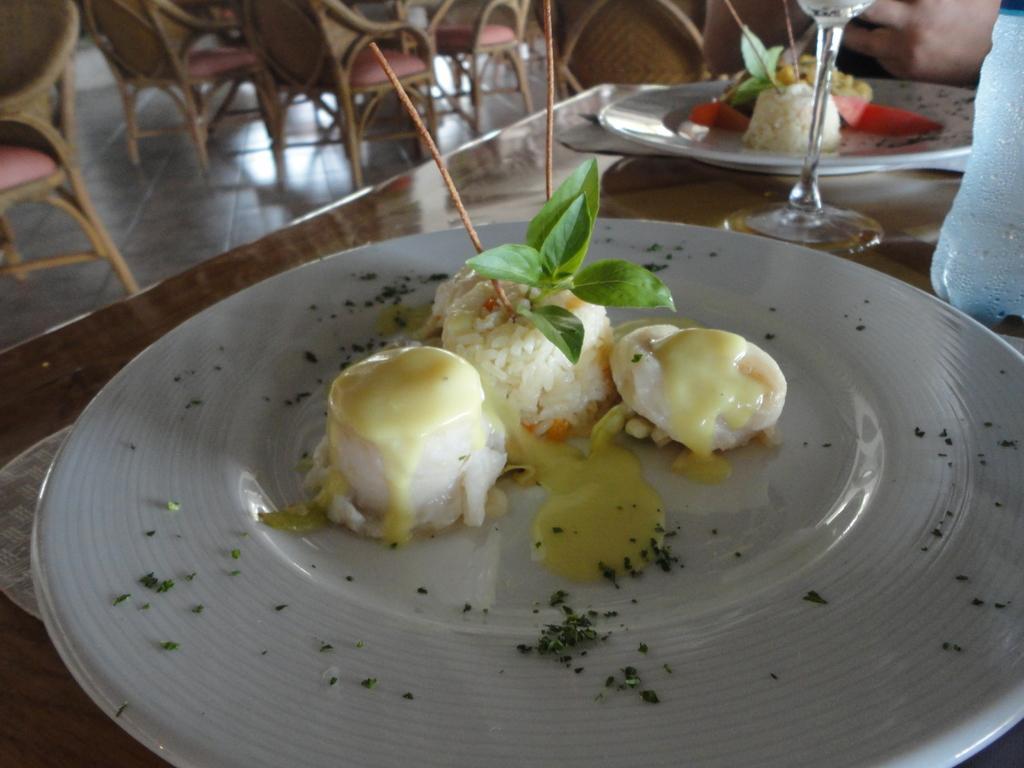Could you give a brief overview of what you see in this image? In this picture there is plate which is placed on a table, which contains food items in it and there are chairs at the top side of the image, there is a another plate and a glass in the top right side of the image. 